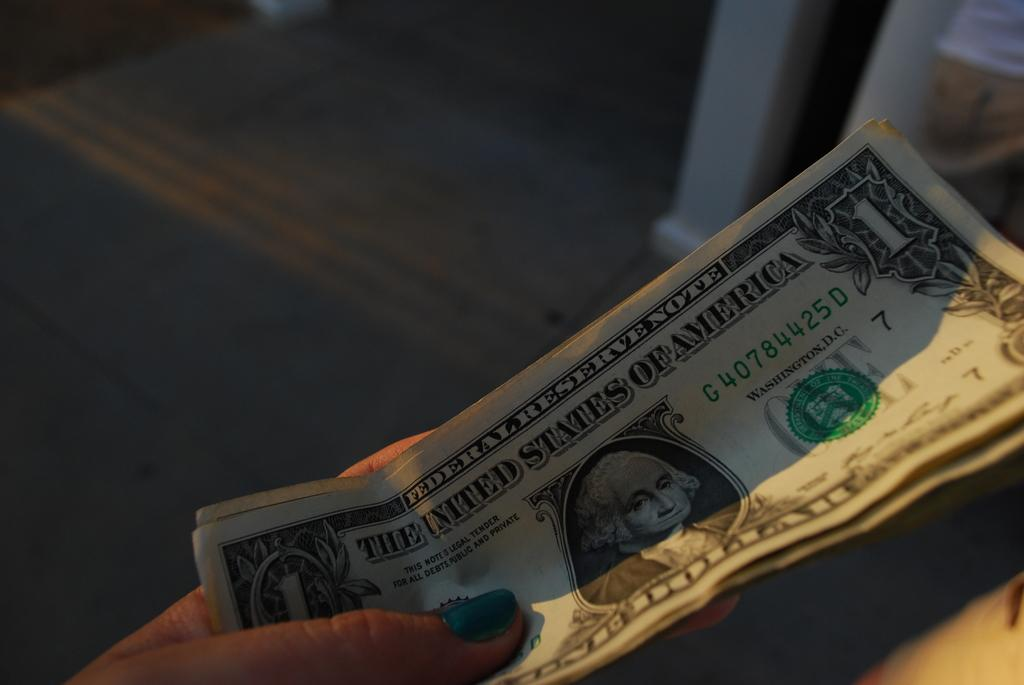What is present in the image? There is a person in the image. What is the person holding in their hand? The person is holding dollar bills in their hand. What type of property is visible in the image? There is no property visible in the image; it only features a person holding dollar bills. What letters can be seen on the boat in the image? There is no boat present in the image, so it is not possible to determine what letters might be on it. 